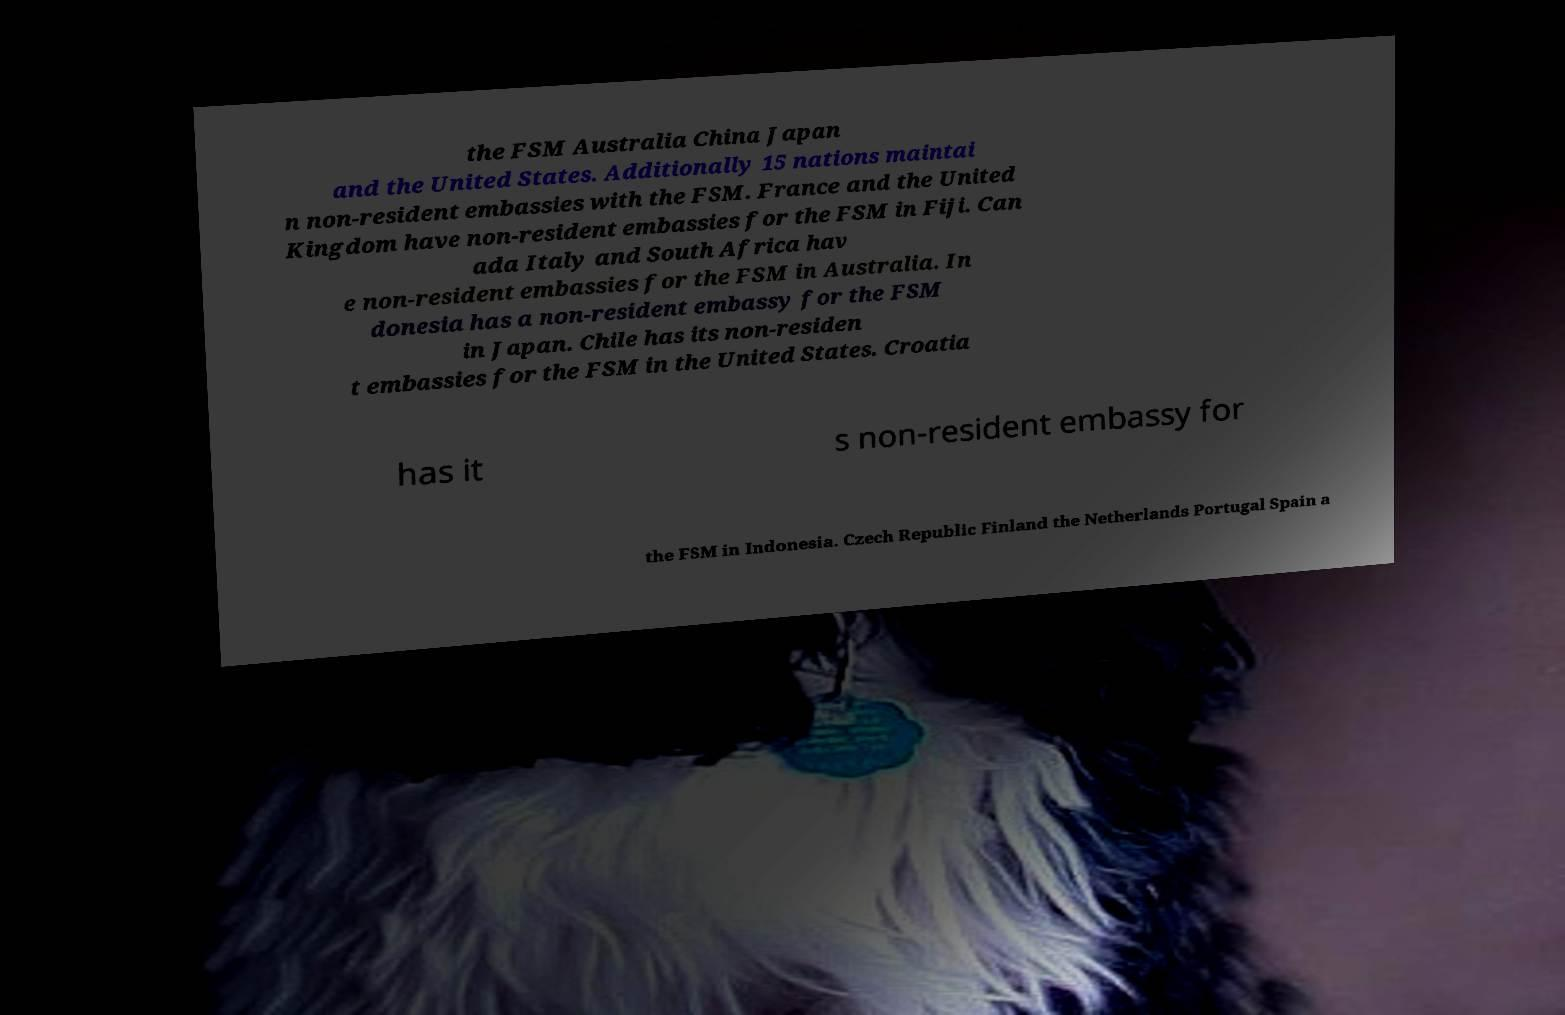Could you extract and type out the text from this image? the FSM Australia China Japan and the United States. Additionally 15 nations maintai n non-resident embassies with the FSM. France and the United Kingdom have non-resident embassies for the FSM in Fiji. Can ada Italy and South Africa hav e non-resident embassies for the FSM in Australia. In donesia has a non-resident embassy for the FSM in Japan. Chile has its non-residen t embassies for the FSM in the United States. Croatia has it s non-resident embassy for the FSM in Indonesia. Czech Republic Finland the Netherlands Portugal Spain a 